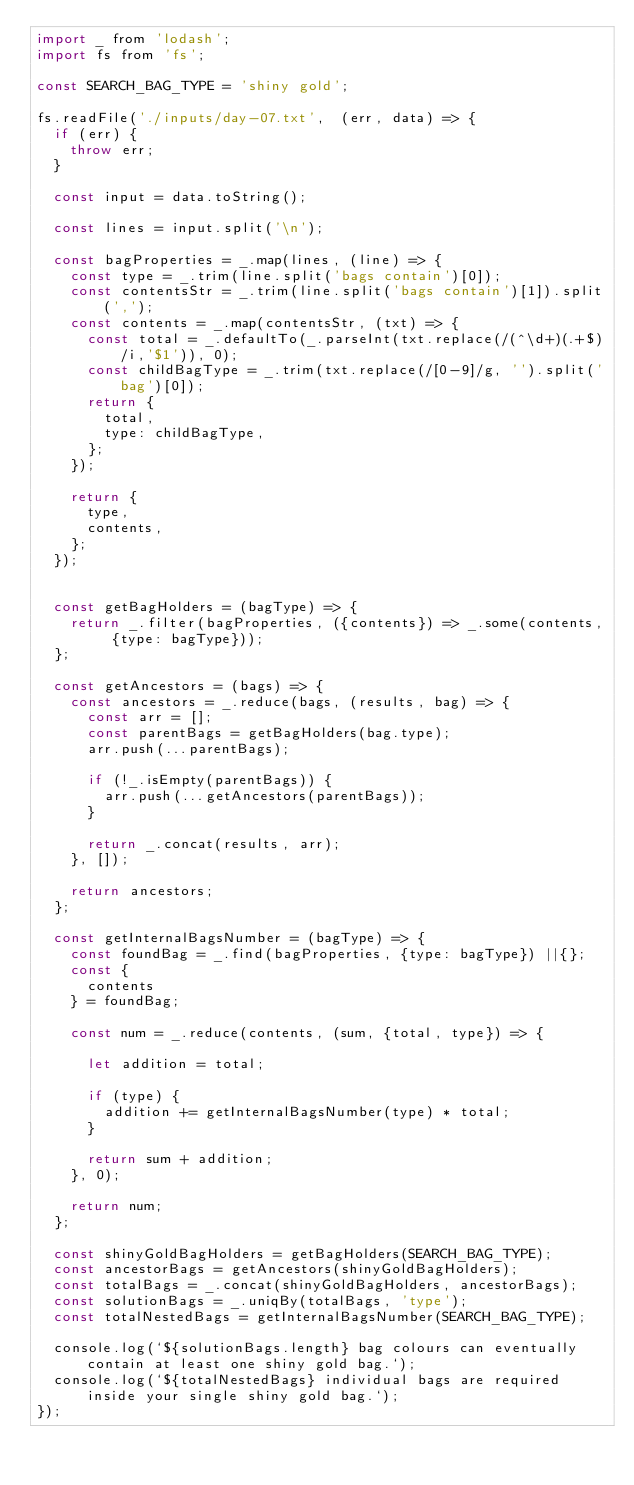Convert code to text. <code><loc_0><loc_0><loc_500><loc_500><_JavaScript_>import _ from 'lodash';
import fs from 'fs';

const SEARCH_BAG_TYPE = 'shiny gold';

fs.readFile('./inputs/day-07.txt',  (err, data) => {
  if (err) {
    throw err;
  }

  const input = data.toString();

  const lines = input.split('\n');

  const bagProperties = _.map(lines, (line) => {
    const type = _.trim(line.split('bags contain')[0]);
    const contentsStr = _.trim(line.split('bags contain')[1]).split(',');
    const contents = _.map(contentsStr, (txt) => {
      const total = _.defaultTo(_.parseInt(txt.replace(/(^\d+)(.+$)/i,'$1')), 0);
      const childBagType = _.trim(txt.replace(/[0-9]/g, '').split('bag')[0]);
      return {
        total,
        type: childBagType,
      };
    });

    return {
      type,
      contents,
    };
  });


  const getBagHolders = (bagType) => {
    return _.filter(bagProperties, ({contents}) => _.some(contents, {type: bagType}));
  };

  const getAncestors = (bags) => {
    const ancestors = _.reduce(bags, (results, bag) => {
      const arr = [];
      const parentBags = getBagHolders(bag.type);
      arr.push(...parentBags);

      if (!_.isEmpty(parentBags)) {
        arr.push(...getAncestors(parentBags));
      }

      return _.concat(results, arr);
    }, []);

    return ancestors;
  };

  const getInternalBagsNumber = (bagType) => {
    const foundBag = _.find(bagProperties, {type: bagType}) ||{};
    const {
      contents
    } = foundBag;

    const num = _.reduce(contents, (sum, {total, type}) => {

      let addition = total;

      if (type) {
        addition += getInternalBagsNumber(type) * total;
      }

      return sum + addition;
    }, 0);

    return num;
  };

  const shinyGoldBagHolders = getBagHolders(SEARCH_BAG_TYPE);
  const ancestorBags = getAncestors(shinyGoldBagHolders);
  const totalBags = _.concat(shinyGoldBagHolders, ancestorBags);
  const solutionBags = _.uniqBy(totalBags, 'type');
  const totalNestedBags = getInternalBagsNumber(SEARCH_BAG_TYPE);

  console.log(`${solutionBags.length} bag colours can eventually contain at least one shiny gold bag.`);
  console.log(`${totalNestedBags} individual bags are required inside your single shiny gold bag.`);
});

</code> 